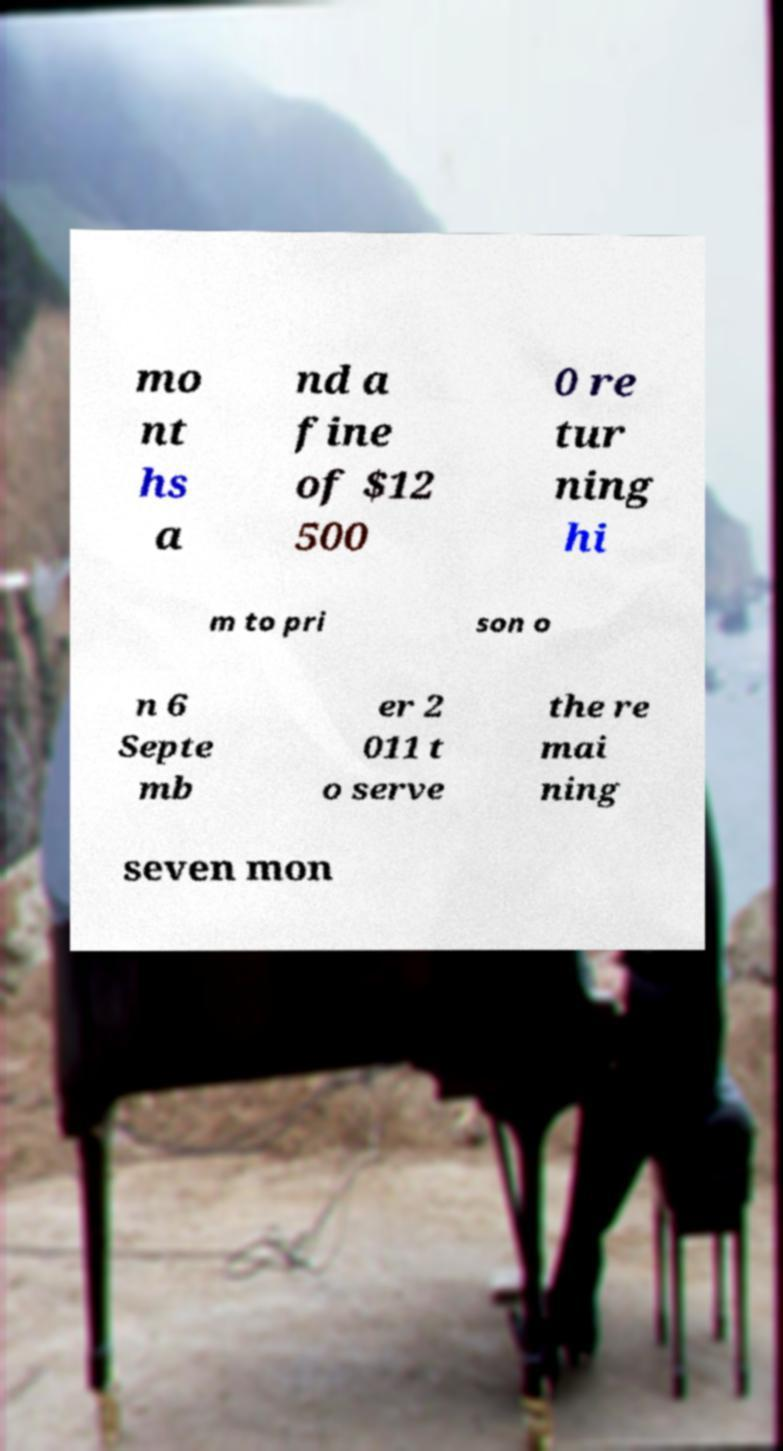I need the written content from this picture converted into text. Can you do that? mo nt hs a nd a fine of $12 500 0 re tur ning hi m to pri son o n 6 Septe mb er 2 011 t o serve the re mai ning seven mon 